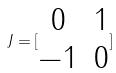Convert formula to latex. <formula><loc_0><loc_0><loc_500><loc_500>J = [ \begin{matrix} 0 & 1 \\ - 1 & 0 \end{matrix} ]</formula> 